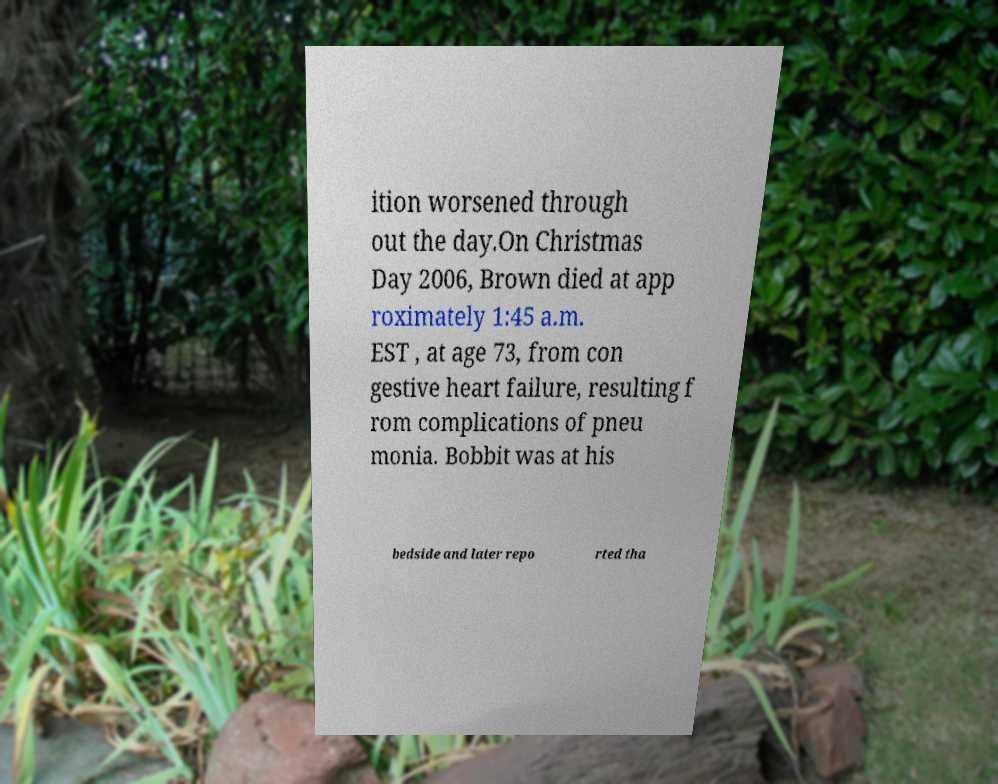There's text embedded in this image that I need extracted. Can you transcribe it verbatim? ition worsened through out the day.On Christmas Day 2006, Brown died at app roximately 1:45 a.m. EST , at age 73, from con gestive heart failure, resulting f rom complications of pneu monia. Bobbit was at his bedside and later repo rted tha 